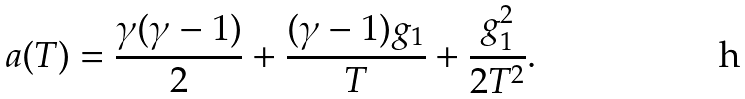<formula> <loc_0><loc_0><loc_500><loc_500>a ( T ) = \frac { \gamma ( \gamma - 1 ) } { 2 } + \frac { ( \gamma - 1 ) g _ { 1 } } { T } + \frac { g ^ { 2 } _ { 1 } } { 2 T ^ { 2 } } .</formula> 